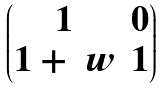<formula> <loc_0><loc_0><loc_500><loc_500>\begin{pmatrix} 1 & 0 \\ 1 + \ w & 1 \end{pmatrix}</formula> 